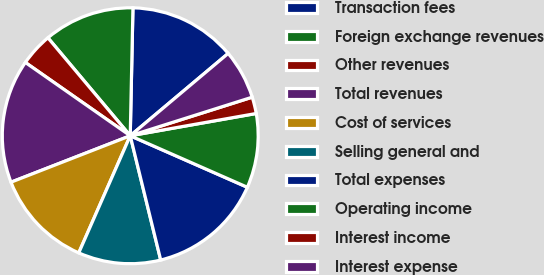<chart> <loc_0><loc_0><loc_500><loc_500><pie_chart><fcel>Transaction fees<fcel>Foreign exchange revenues<fcel>Other revenues<fcel>Total revenues<fcel>Cost of services<fcel>Selling general and<fcel>Total expenses<fcel>Operating income<fcel>Interest income<fcel>Interest expense<nl><fcel>13.54%<fcel>11.46%<fcel>4.17%<fcel>15.62%<fcel>12.5%<fcel>10.42%<fcel>14.58%<fcel>9.38%<fcel>2.09%<fcel>6.25%<nl></chart> 